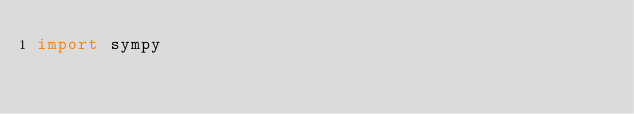<code> <loc_0><loc_0><loc_500><loc_500><_Python_>import sympy
</code> 